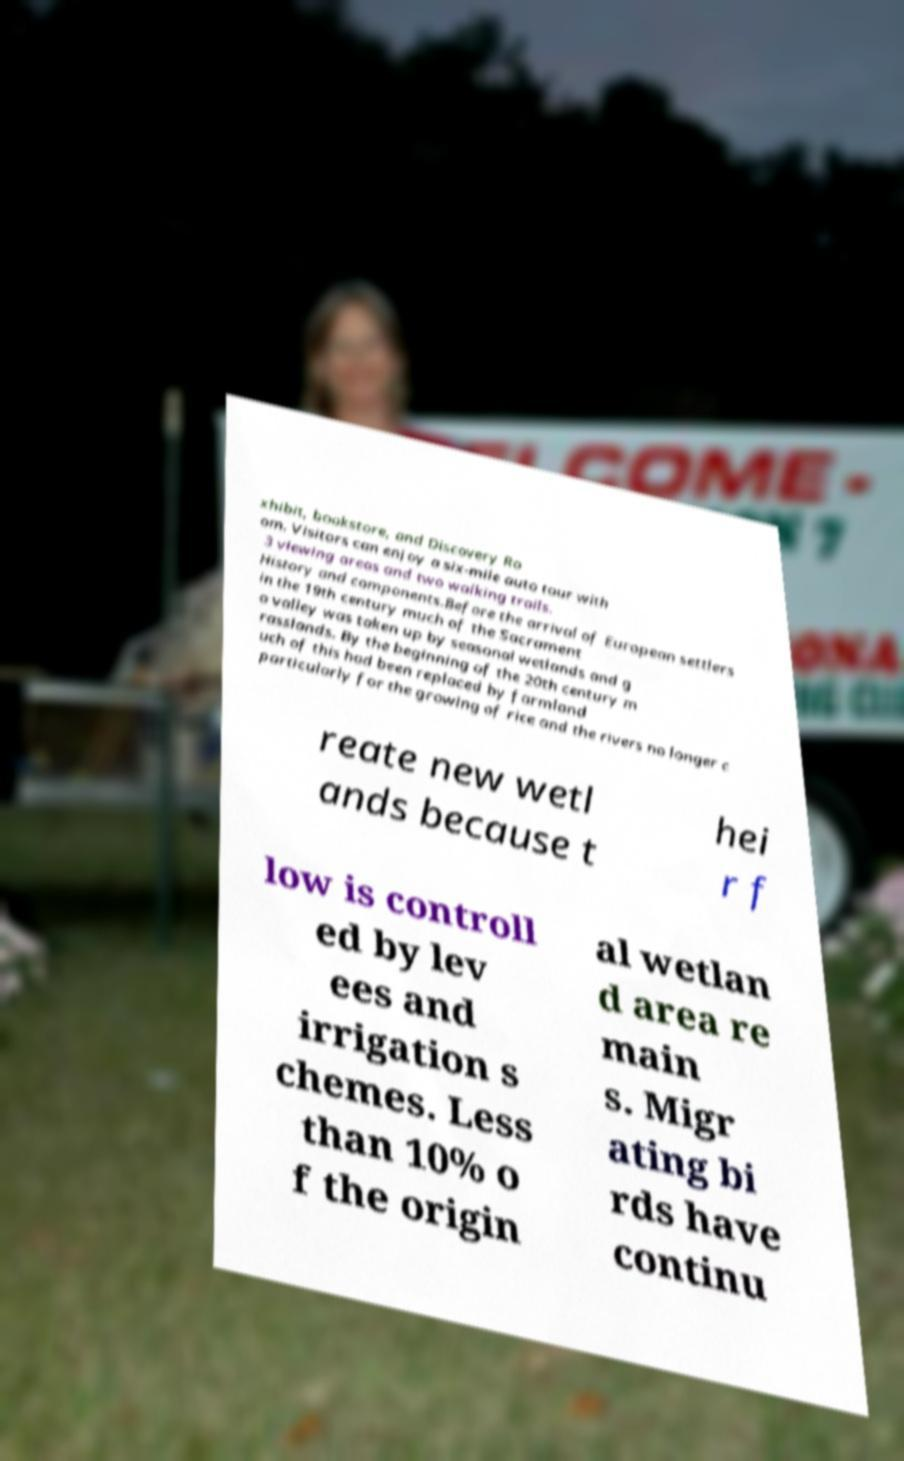There's text embedded in this image that I need extracted. Can you transcribe it verbatim? xhibit, bookstore, and Discovery Ro om. Visitors can enjoy a six-mile auto tour with 3 viewing areas and two walking trails. History and components.Before the arrival of European settlers in the 19th century much of the Sacrament o valley was taken up by seasonal wetlands and g rasslands. By the beginning of the 20th century m uch of this had been replaced by farmland particularly for the growing of rice and the rivers no longer c reate new wetl ands because t hei r f low is controll ed by lev ees and irrigation s chemes. Less than 10% o f the origin al wetlan d area re main s. Migr ating bi rds have continu 